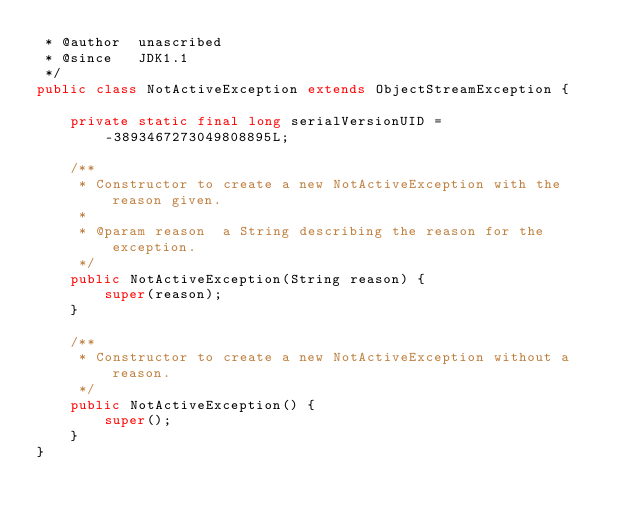<code> <loc_0><loc_0><loc_500><loc_500><_Java_> * @author  unascribed
 * @since   JDK1.1
 */
public class NotActiveException extends ObjectStreamException {

    private static final long serialVersionUID = -3893467273049808895L;

    /**
     * Constructor to create a new NotActiveException with the reason given.
     *
     * @param reason  a String describing the reason for the exception.
     */
    public NotActiveException(String reason) {
        super(reason);
    }

    /**
     * Constructor to create a new NotActiveException without a reason.
     */
    public NotActiveException() {
        super();
    }
}
</code> 